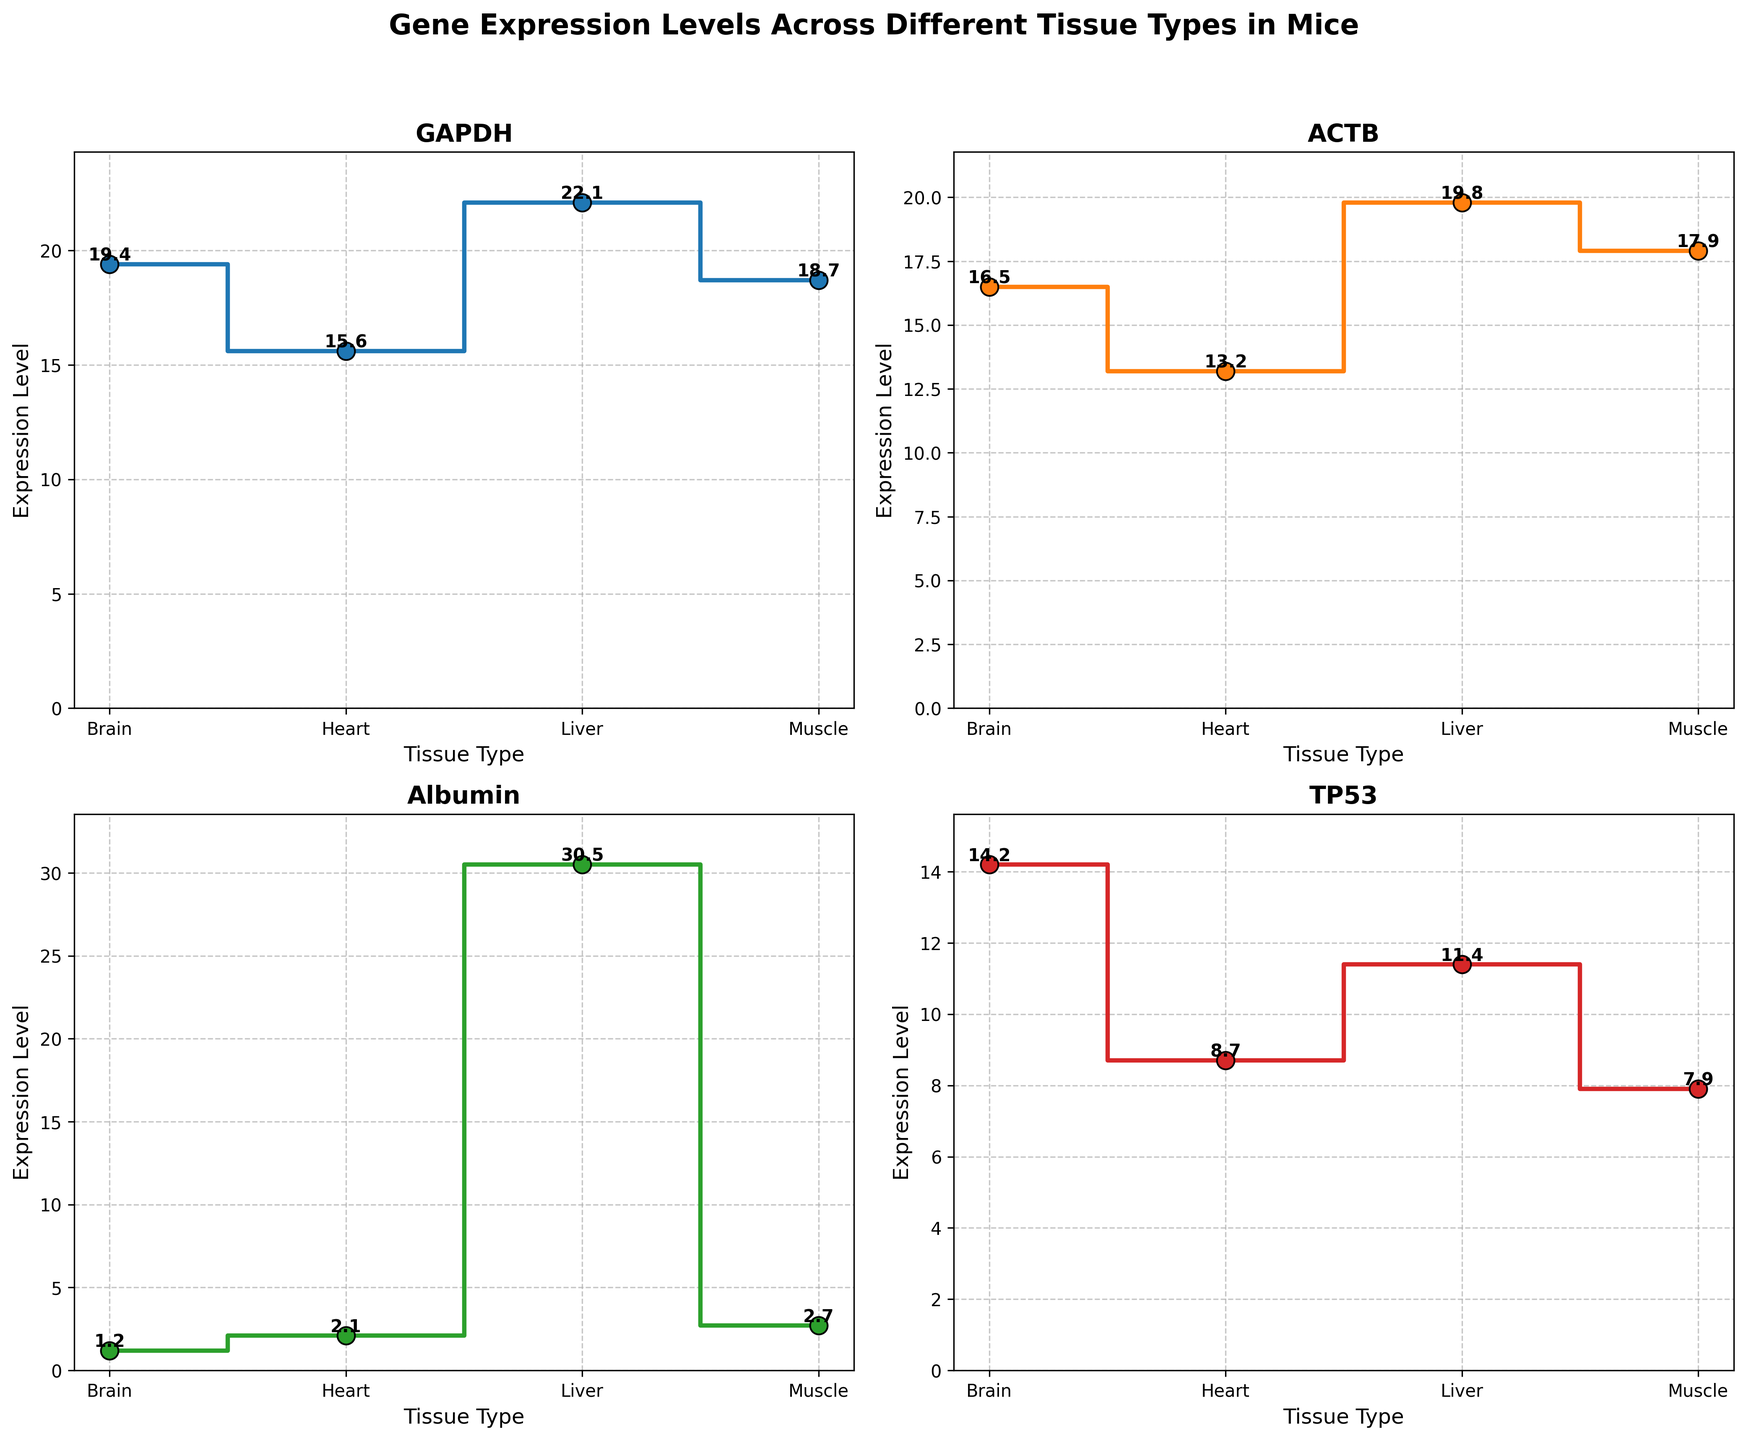What's the title of the figure? The title of the figure is prominently displayed at the top in bold and larger font size.
Answer: Gene Expression Levels Across Different Tissue Types in Mice What is the expression level of GAPDH in the Heart tissue? Locate the GAPDH graph and find the Heart tissue on the x-axis. The corresponding y-axis value is the expression level.
Answer: 15.6 Which tissue type has the highest expression level for Albumin? Locate the Albumin graph, then identify the tissue with the highest y-axis value.
Answer: Liver Which gene has the highest expression level in the Brain tissue? Compare the y-axis values for Brain tissue across all gene graphs, and identify the highest one.
Answer: TP53 What's the difference in expression levels of TP53 between Liver and Muscle tissues? Locate the TP53 graph, find the y-axis values for Liver and Muscle tissues, and calculate their difference (11.4 - 7.9).
Answer: 3.5 How many genes are displayed in the figure? Count the number of subplots or different gene titles.
Answer: 4 Which gene has the lowest expression level in Muscle tissue? Compare the y-axis values for Muscle tissue across all gene graphs, and identify the lowest one.
Answer: Albumin What's the average expression level of ACTB across all tissues? Locate the ACTB graph, sum the expression levels for all tissues, then divide by the number of tissues ((13.2 + 19.8 + 16.5 + 17.9) / 4).
Answer: 16.85 Is there any tissue where GAPDH and ACTB have the same expression level? Compare the y-axis values for GAPDH and ACTB graphs for each tissue, checking for any match.
Answer: No What's the total expression level of GAPDH across all tissues? Locate the GAPDH graph, sum the expression levels for all tissues (15.6 + 22.1 + 19.4 + 18.7).
Answer: 75.8 